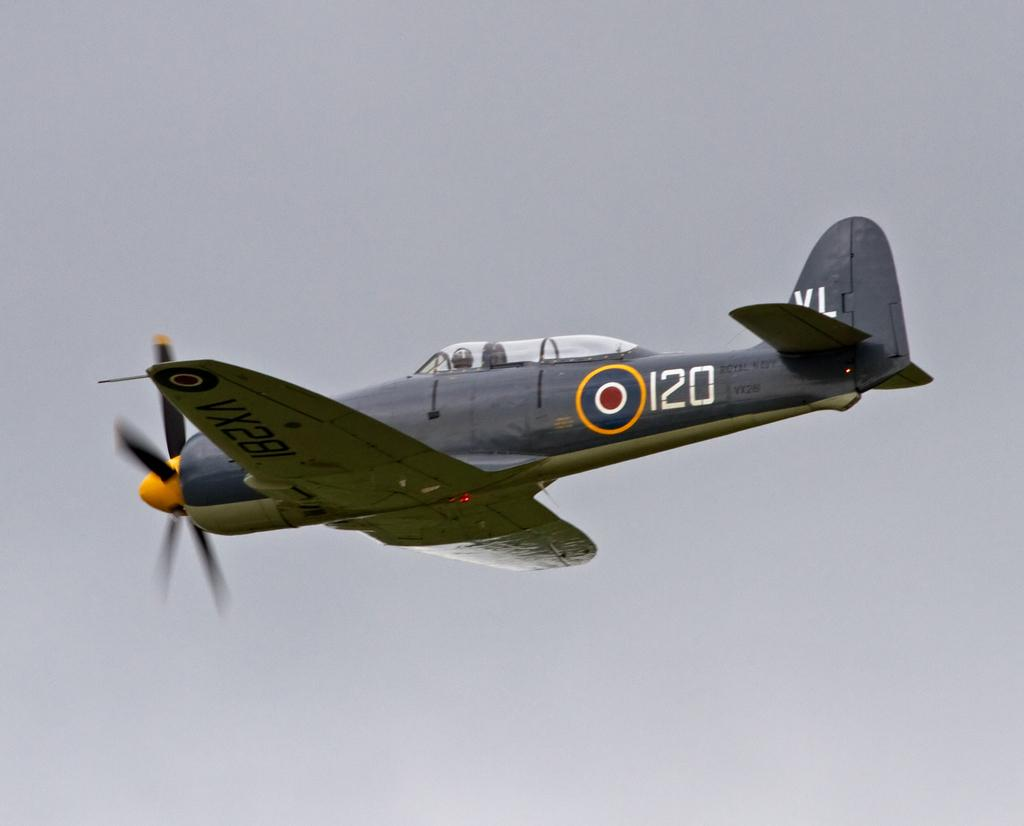<image>
Summarize the visual content of the image. A gray single prop airplane with a label "120" flies over head. 